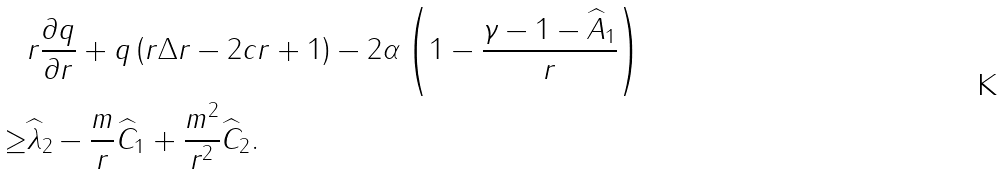<formula> <loc_0><loc_0><loc_500><loc_500>& r \frac { \partial q } { \partial r } + q \left ( r \Delta r - 2 c r + 1 \right ) - 2 \alpha \left ( 1 - \frac { \gamma - 1 - \widehat { A } _ { 1 } } { r } \right ) \\ \geq & \widehat { \lambda } _ { 2 } - \frac { m } { r } \widehat { C } _ { 1 } + \frac { m ^ { 2 } } { r ^ { 2 } } \widehat { C } _ { 2 } .</formula> 